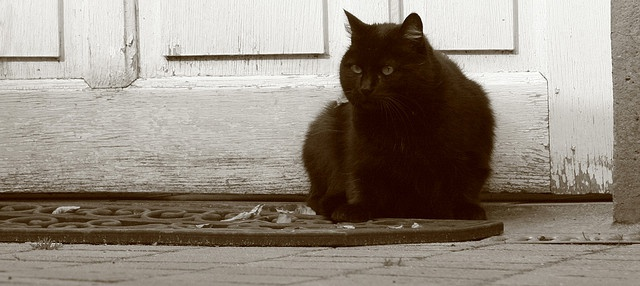Describe the objects in this image and their specific colors. I can see a cat in lightgray, black, maroon, and gray tones in this image. 